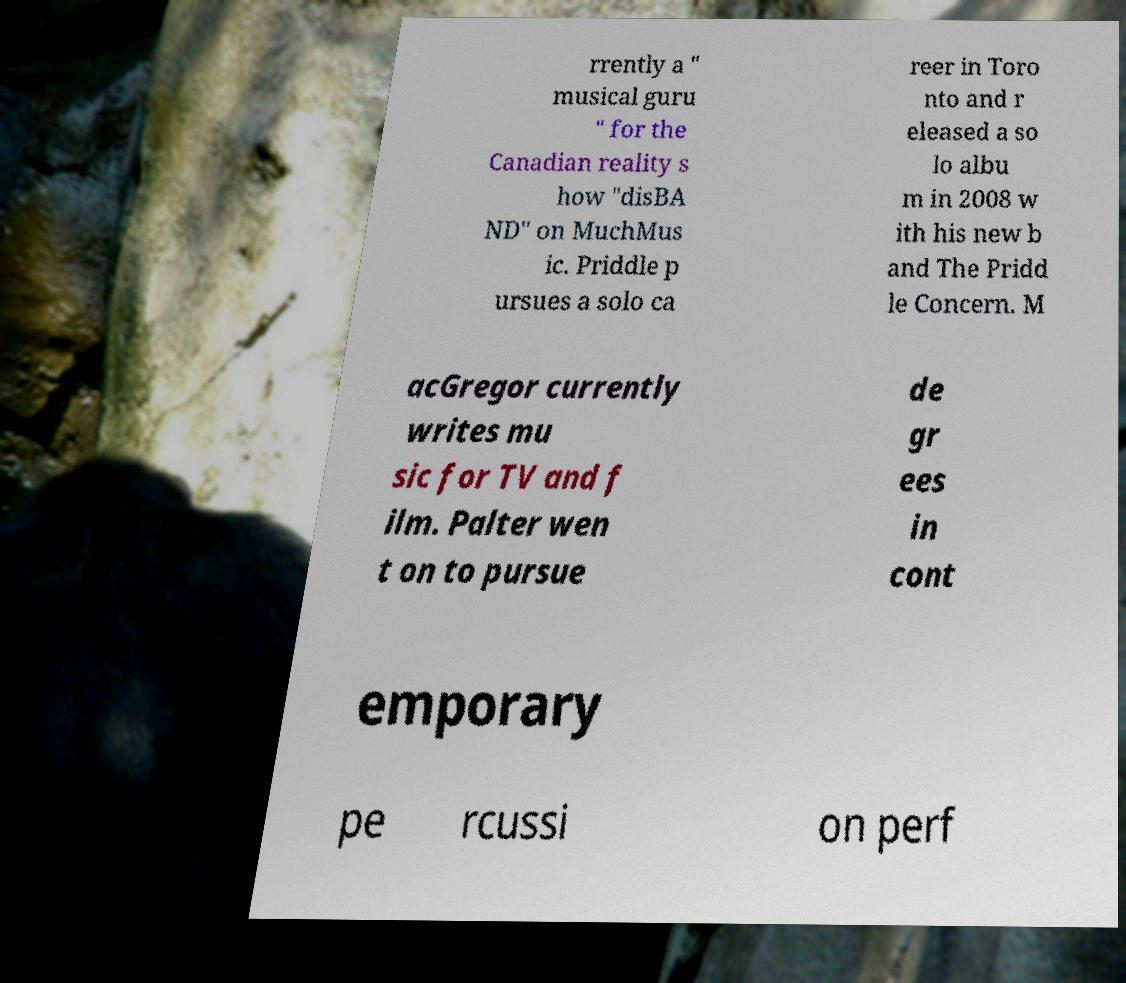Please read and relay the text visible in this image. What does it say? rrently a " musical guru " for the Canadian reality s how "disBA ND" on MuchMus ic. Priddle p ursues a solo ca reer in Toro nto and r eleased a so lo albu m in 2008 w ith his new b and The Pridd le Concern. M acGregor currently writes mu sic for TV and f ilm. Palter wen t on to pursue de gr ees in cont emporary pe rcussi on perf 